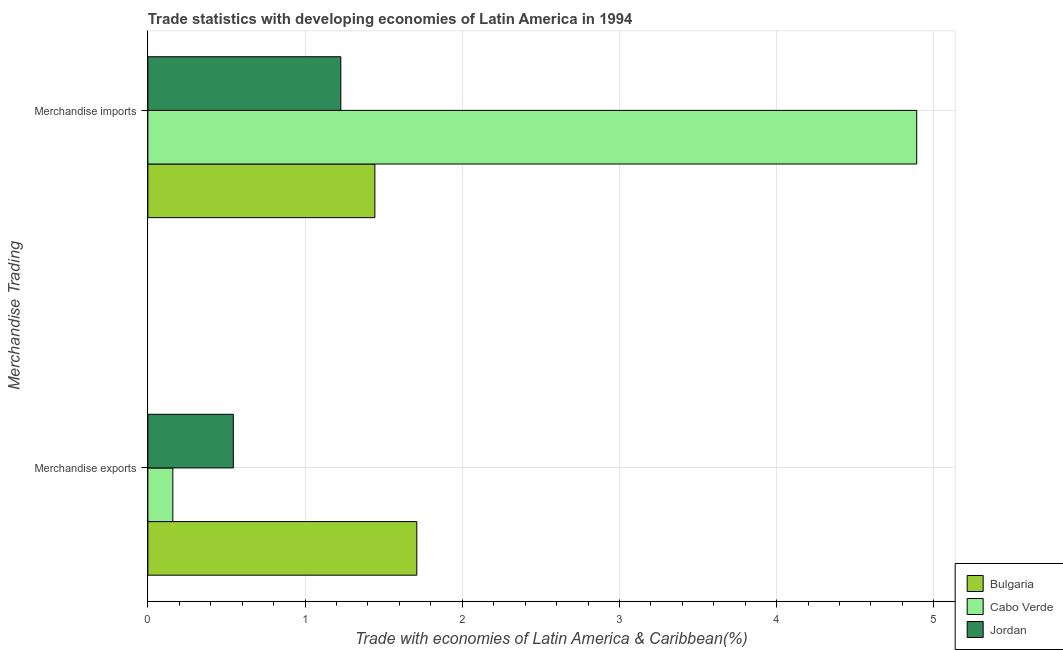How many groups of bars are there?
Ensure brevity in your answer.  2. How many bars are there on the 1st tick from the top?
Provide a succinct answer. 3. How many bars are there on the 1st tick from the bottom?
Make the answer very short. 3. What is the merchandise exports in Jordan?
Give a very brief answer. 0.54. Across all countries, what is the maximum merchandise exports?
Offer a very short reply. 1.71. Across all countries, what is the minimum merchandise imports?
Give a very brief answer. 1.23. In which country was the merchandise imports maximum?
Make the answer very short. Cabo Verde. In which country was the merchandise exports minimum?
Offer a terse response. Cabo Verde. What is the total merchandise imports in the graph?
Make the answer very short. 7.56. What is the difference between the merchandise imports in Jordan and that in Bulgaria?
Keep it short and to the point. -0.22. What is the difference between the merchandise imports in Bulgaria and the merchandise exports in Jordan?
Offer a very short reply. 0.9. What is the average merchandise imports per country?
Make the answer very short. 2.52. What is the difference between the merchandise imports and merchandise exports in Jordan?
Provide a succinct answer. 0.68. In how many countries, is the merchandise imports greater than 2.8 %?
Provide a short and direct response. 1. What is the ratio of the merchandise exports in Jordan to that in Cabo Verde?
Offer a very short reply. 3.42. Is the merchandise imports in Jordan less than that in Cabo Verde?
Provide a short and direct response. Yes. In how many countries, is the merchandise imports greater than the average merchandise imports taken over all countries?
Make the answer very short. 1. What does the 3rd bar from the top in Merchandise imports represents?
Your answer should be compact. Bulgaria. What does the 1st bar from the bottom in Merchandise imports represents?
Make the answer very short. Bulgaria. Are all the bars in the graph horizontal?
Offer a terse response. Yes. How many countries are there in the graph?
Provide a succinct answer. 3. What is the difference between two consecutive major ticks on the X-axis?
Offer a very short reply. 1. Are the values on the major ticks of X-axis written in scientific E-notation?
Your answer should be very brief. No. Does the graph contain any zero values?
Provide a short and direct response. No. Does the graph contain grids?
Your response must be concise. Yes. Where does the legend appear in the graph?
Give a very brief answer. Bottom right. How many legend labels are there?
Keep it short and to the point. 3. What is the title of the graph?
Provide a short and direct response. Trade statistics with developing economies of Latin America in 1994. What is the label or title of the X-axis?
Your response must be concise. Trade with economies of Latin America & Caribbean(%). What is the label or title of the Y-axis?
Provide a short and direct response. Merchandise Trading. What is the Trade with economies of Latin America & Caribbean(%) in Bulgaria in Merchandise exports?
Offer a terse response. 1.71. What is the Trade with economies of Latin America & Caribbean(%) of Cabo Verde in Merchandise exports?
Provide a succinct answer. 0.16. What is the Trade with economies of Latin America & Caribbean(%) in Jordan in Merchandise exports?
Ensure brevity in your answer.  0.54. What is the Trade with economies of Latin America & Caribbean(%) of Bulgaria in Merchandise imports?
Your answer should be very brief. 1.44. What is the Trade with economies of Latin America & Caribbean(%) in Cabo Verde in Merchandise imports?
Your answer should be very brief. 4.89. What is the Trade with economies of Latin America & Caribbean(%) in Jordan in Merchandise imports?
Your response must be concise. 1.23. Across all Merchandise Trading, what is the maximum Trade with economies of Latin America & Caribbean(%) of Bulgaria?
Your answer should be very brief. 1.71. Across all Merchandise Trading, what is the maximum Trade with economies of Latin America & Caribbean(%) of Cabo Verde?
Make the answer very short. 4.89. Across all Merchandise Trading, what is the maximum Trade with economies of Latin America & Caribbean(%) in Jordan?
Keep it short and to the point. 1.23. Across all Merchandise Trading, what is the minimum Trade with economies of Latin America & Caribbean(%) in Bulgaria?
Ensure brevity in your answer.  1.44. Across all Merchandise Trading, what is the minimum Trade with economies of Latin America & Caribbean(%) of Cabo Verde?
Offer a very short reply. 0.16. Across all Merchandise Trading, what is the minimum Trade with economies of Latin America & Caribbean(%) of Jordan?
Offer a very short reply. 0.54. What is the total Trade with economies of Latin America & Caribbean(%) in Bulgaria in the graph?
Give a very brief answer. 3.15. What is the total Trade with economies of Latin America & Caribbean(%) of Cabo Verde in the graph?
Keep it short and to the point. 5.05. What is the total Trade with economies of Latin America & Caribbean(%) in Jordan in the graph?
Keep it short and to the point. 1.77. What is the difference between the Trade with economies of Latin America & Caribbean(%) of Bulgaria in Merchandise exports and that in Merchandise imports?
Your response must be concise. 0.27. What is the difference between the Trade with economies of Latin America & Caribbean(%) in Cabo Verde in Merchandise exports and that in Merchandise imports?
Ensure brevity in your answer.  -4.73. What is the difference between the Trade with economies of Latin America & Caribbean(%) of Jordan in Merchandise exports and that in Merchandise imports?
Make the answer very short. -0.68. What is the difference between the Trade with economies of Latin America & Caribbean(%) of Bulgaria in Merchandise exports and the Trade with economies of Latin America & Caribbean(%) of Cabo Verde in Merchandise imports?
Offer a very short reply. -3.18. What is the difference between the Trade with economies of Latin America & Caribbean(%) in Bulgaria in Merchandise exports and the Trade with economies of Latin America & Caribbean(%) in Jordan in Merchandise imports?
Ensure brevity in your answer.  0.48. What is the difference between the Trade with economies of Latin America & Caribbean(%) of Cabo Verde in Merchandise exports and the Trade with economies of Latin America & Caribbean(%) of Jordan in Merchandise imports?
Your response must be concise. -1.07. What is the average Trade with economies of Latin America & Caribbean(%) in Bulgaria per Merchandise Trading?
Make the answer very short. 1.58. What is the average Trade with economies of Latin America & Caribbean(%) in Cabo Verde per Merchandise Trading?
Keep it short and to the point. 2.52. What is the average Trade with economies of Latin America & Caribbean(%) of Jordan per Merchandise Trading?
Provide a succinct answer. 0.89. What is the difference between the Trade with economies of Latin America & Caribbean(%) of Bulgaria and Trade with economies of Latin America & Caribbean(%) of Cabo Verde in Merchandise exports?
Make the answer very short. 1.55. What is the difference between the Trade with economies of Latin America & Caribbean(%) in Bulgaria and Trade with economies of Latin America & Caribbean(%) in Jordan in Merchandise exports?
Ensure brevity in your answer.  1.17. What is the difference between the Trade with economies of Latin America & Caribbean(%) of Cabo Verde and Trade with economies of Latin America & Caribbean(%) of Jordan in Merchandise exports?
Provide a succinct answer. -0.38. What is the difference between the Trade with economies of Latin America & Caribbean(%) of Bulgaria and Trade with economies of Latin America & Caribbean(%) of Cabo Verde in Merchandise imports?
Make the answer very short. -3.45. What is the difference between the Trade with economies of Latin America & Caribbean(%) of Bulgaria and Trade with economies of Latin America & Caribbean(%) of Jordan in Merchandise imports?
Provide a succinct answer. 0.22. What is the difference between the Trade with economies of Latin America & Caribbean(%) of Cabo Verde and Trade with economies of Latin America & Caribbean(%) of Jordan in Merchandise imports?
Provide a short and direct response. 3.66. What is the ratio of the Trade with economies of Latin America & Caribbean(%) of Bulgaria in Merchandise exports to that in Merchandise imports?
Provide a succinct answer. 1.18. What is the ratio of the Trade with economies of Latin America & Caribbean(%) in Cabo Verde in Merchandise exports to that in Merchandise imports?
Give a very brief answer. 0.03. What is the ratio of the Trade with economies of Latin America & Caribbean(%) in Jordan in Merchandise exports to that in Merchandise imports?
Offer a terse response. 0.44. What is the difference between the highest and the second highest Trade with economies of Latin America & Caribbean(%) of Bulgaria?
Keep it short and to the point. 0.27. What is the difference between the highest and the second highest Trade with economies of Latin America & Caribbean(%) of Cabo Verde?
Give a very brief answer. 4.73. What is the difference between the highest and the second highest Trade with economies of Latin America & Caribbean(%) in Jordan?
Make the answer very short. 0.68. What is the difference between the highest and the lowest Trade with economies of Latin America & Caribbean(%) of Bulgaria?
Your response must be concise. 0.27. What is the difference between the highest and the lowest Trade with economies of Latin America & Caribbean(%) in Cabo Verde?
Your answer should be very brief. 4.73. What is the difference between the highest and the lowest Trade with economies of Latin America & Caribbean(%) in Jordan?
Offer a very short reply. 0.68. 